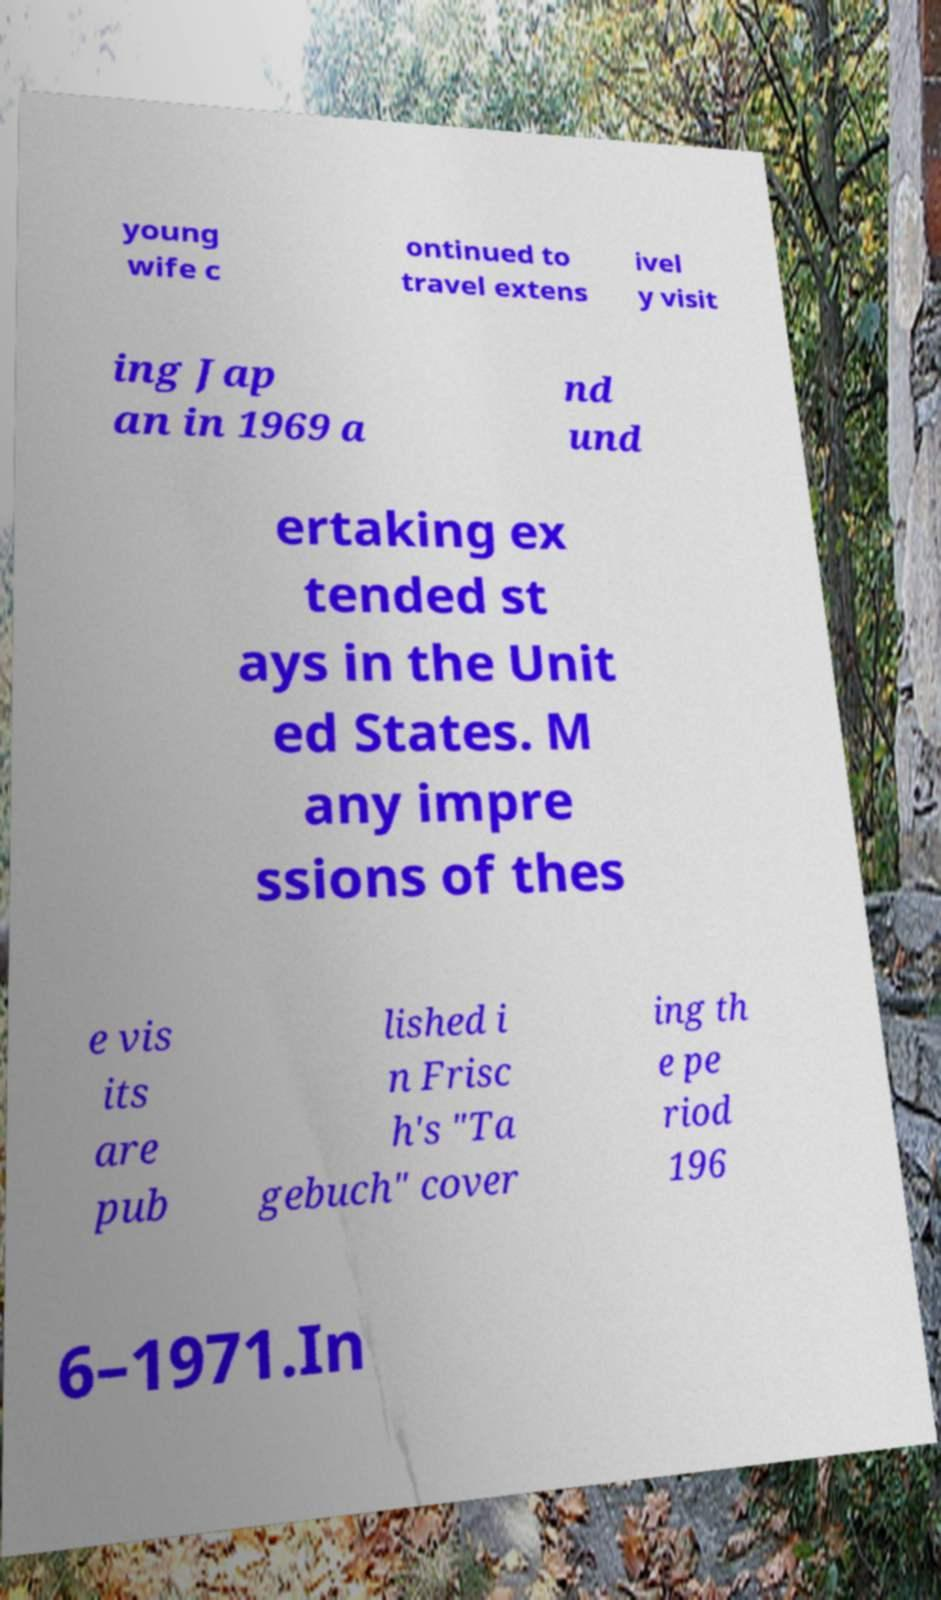Can you read and provide the text displayed in the image?This photo seems to have some interesting text. Can you extract and type it out for me? young wife c ontinued to travel extens ivel y visit ing Jap an in 1969 a nd und ertaking ex tended st ays in the Unit ed States. M any impre ssions of thes e vis its are pub lished i n Frisc h's "Ta gebuch" cover ing th e pe riod 196 6–1971.In 